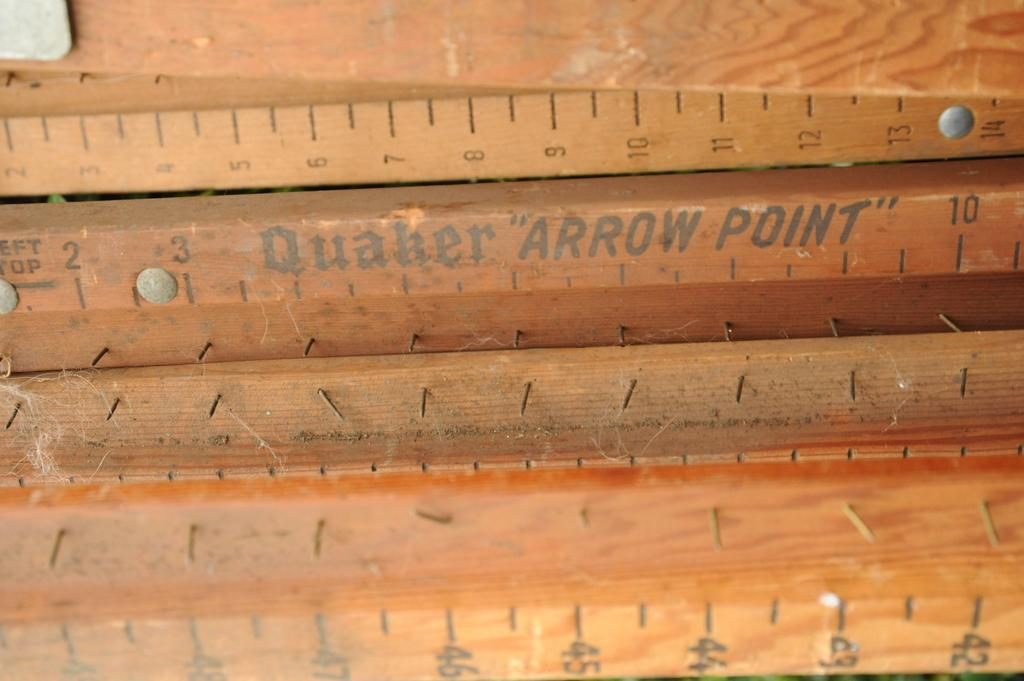<image>
Summarize the visual content of the image. A bunch of rulers, one labeled Quaker Arrow Point. 